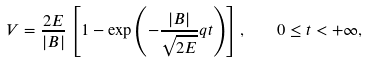<formula> <loc_0><loc_0><loc_500><loc_500>V = \frac { 2 E } { | B | } \left [ 1 - \exp \left ( - \frac { | B | } { \sqrt { 2 E } } q t \right ) \right ] , \quad 0 \leq t < + \infty ,</formula> 